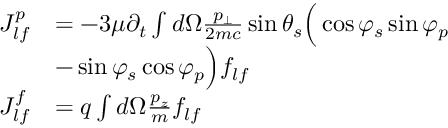<formula> <loc_0><loc_0><loc_500><loc_500>\begin{array} { r l } { J _ { l f } ^ { p } } & { = - 3 \mu \partial _ { t } \int d \Omega \frac { p _ { \bot } } { 2 m c } \sin \theta _ { s } \left ( \cos \varphi _ { s } \sin \varphi _ { p } } \\ & { - \sin \varphi _ { s } \cos \varphi _ { p } \right ) f _ { l f } } \\ { J _ { l f } ^ { f } } & { = q \int d \Omega \frac { p _ { z } } { m } f _ { l f } } \end{array}</formula> 